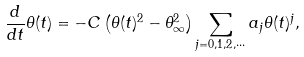Convert formula to latex. <formula><loc_0><loc_0><loc_500><loc_500>\frac { d } { d t } \theta ( t ) = - C \left ( \theta ( t ) ^ { 2 } - \theta _ { \infty } ^ { 2 } \right ) \sum _ { j = 0 , 1 , 2 , \cdots } a _ { j } \theta ( t ) ^ { j } ,</formula> 